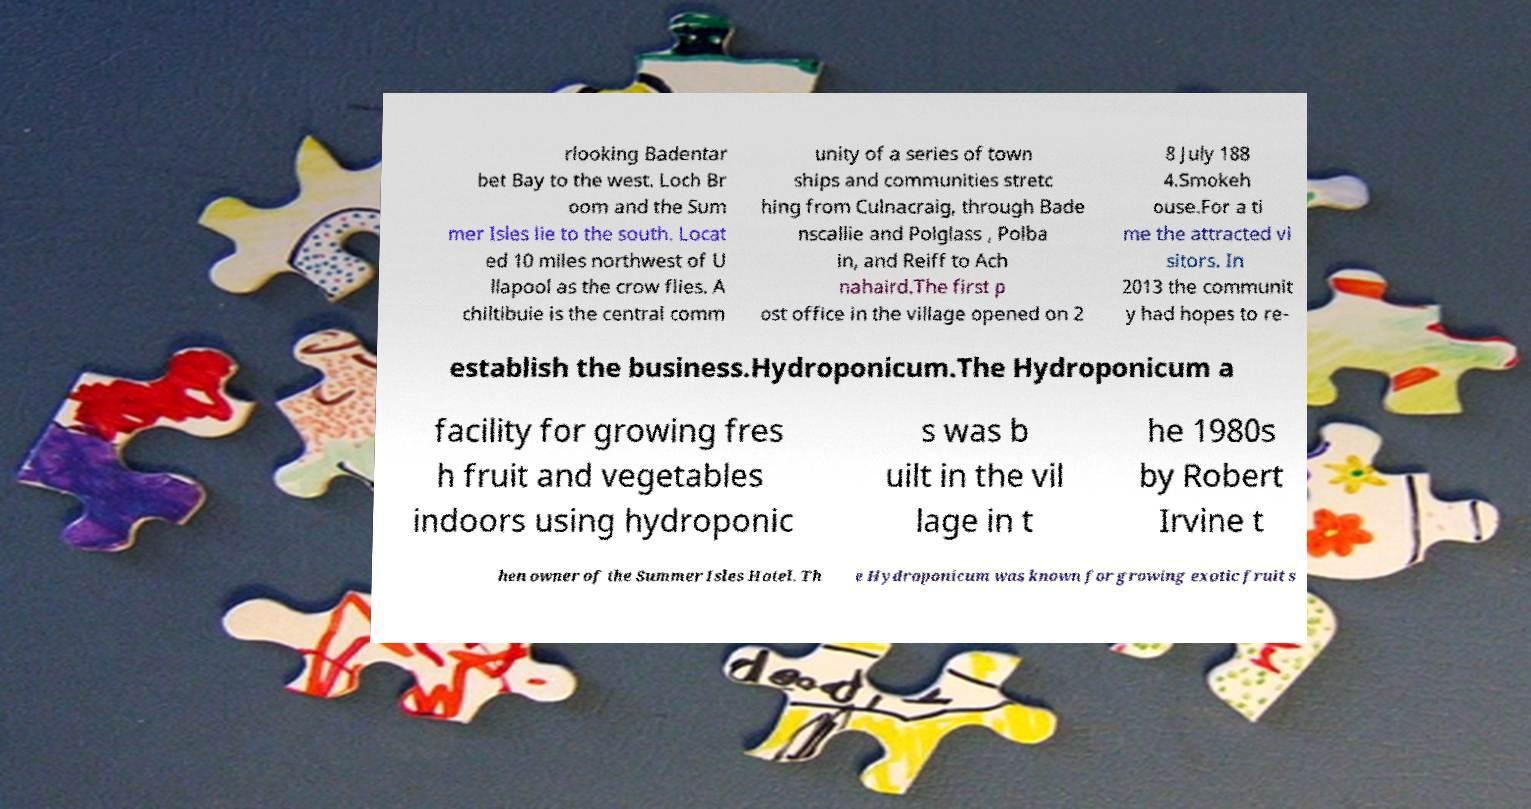Could you assist in decoding the text presented in this image and type it out clearly? rlooking Badentar bet Bay to the west. Loch Br oom and the Sum mer Isles lie to the south. Locat ed 10 miles northwest of U llapool as the crow flies. A chiltibuie is the central comm unity of a series of town ships and communities stretc hing from Culnacraig, through Bade nscallie and Polglass , Polba in, and Reiff to Ach nahaird.The first p ost office in the village opened on 2 8 July 188 4.Smokeh ouse.For a ti me the attracted vi sitors. In 2013 the communit y had hopes to re- establish the business.Hydroponicum.The Hydroponicum a facility for growing fres h fruit and vegetables indoors using hydroponic s was b uilt in the vil lage in t he 1980s by Robert Irvine t hen owner of the Summer Isles Hotel. Th e Hydroponicum was known for growing exotic fruit s 